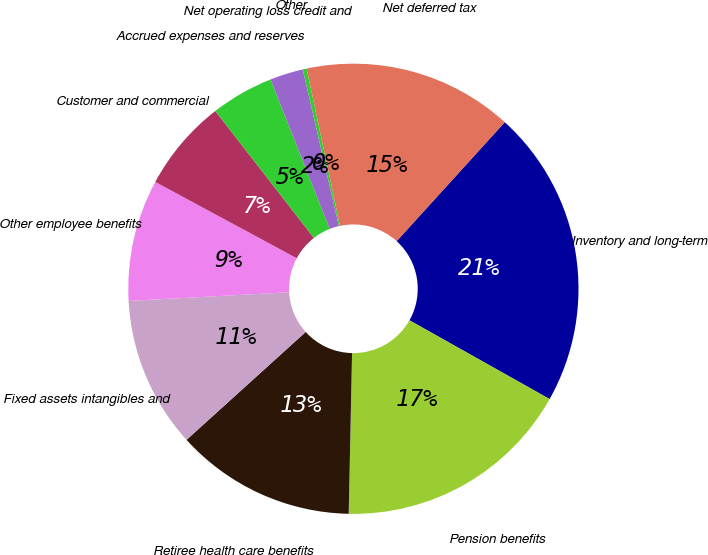Convert chart to OTSL. <chart><loc_0><loc_0><loc_500><loc_500><pie_chart><fcel>Inventory and long-term<fcel>Pension benefits<fcel>Retiree health care benefits<fcel>Fixed assets intangibles and<fcel>Other employee benefits<fcel>Customer and commercial<fcel>Accrued expenses and reserves<fcel>Net operating loss credit and<fcel>Other<fcel>Net deferred tax<nl><fcel>21.41%<fcel>17.18%<fcel>12.96%<fcel>10.85%<fcel>8.73%<fcel>6.62%<fcel>4.51%<fcel>2.39%<fcel>0.28%<fcel>15.07%<nl></chart> 